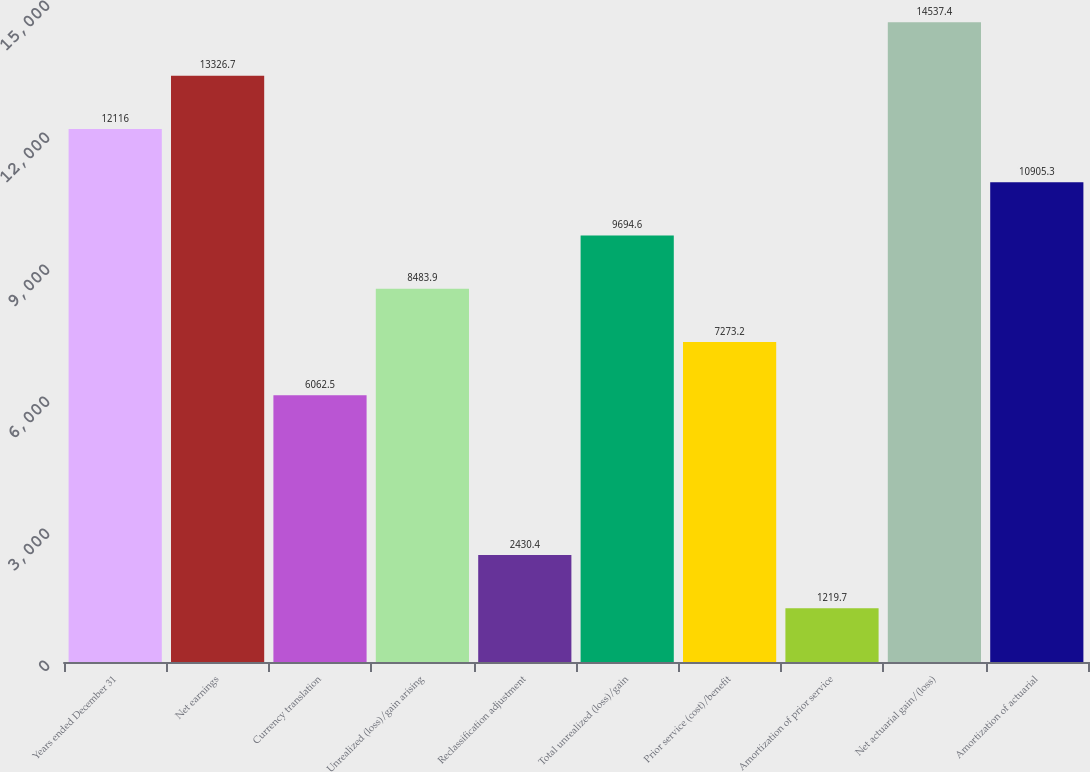<chart> <loc_0><loc_0><loc_500><loc_500><bar_chart><fcel>Years ended December 31<fcel>Net earnings<fcel>Currency translation<fcel>Unrealized (loss)/gain arising<fcel>Reclassification adjustment<fcel>Total unrealized (loss)/gain<fcel>Prior service (cost)/benefit<fcel>Amortization of prior service<fcel>Net actuarial gain/(loss)<fcel>Amortization of actuarial<nl><fcel>12116<fcel>13326.7<fcel>6062.5<fcel>8483.9<fcel>2430.4<fcel>9694.6<fcel>7273.2<fcel>1219.7<fcel>14537.4<fcel>10905.3<nl></chart> 